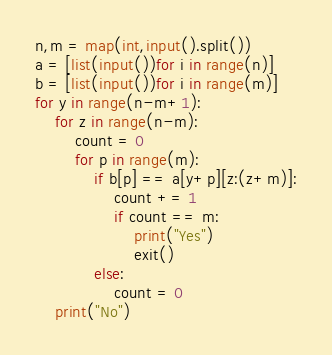Convert code to text. <code><loc_0><loc_0><loc_500><loc_500><_Python_>n,m = map(int,input().split())
a = [list(input())for i in range(n)]
b = [list(input())for i in range(m)]
for y in range(n-m+1):
    for z in range(n-m):
        count = 0
        for p in range(m):
            if b[p] == a[y+p][z:(z+m)]:
                count += 1
                if count == m:
                    print("Yes")
                    exit()
            else:
                count = 0
    print("No")</code> 